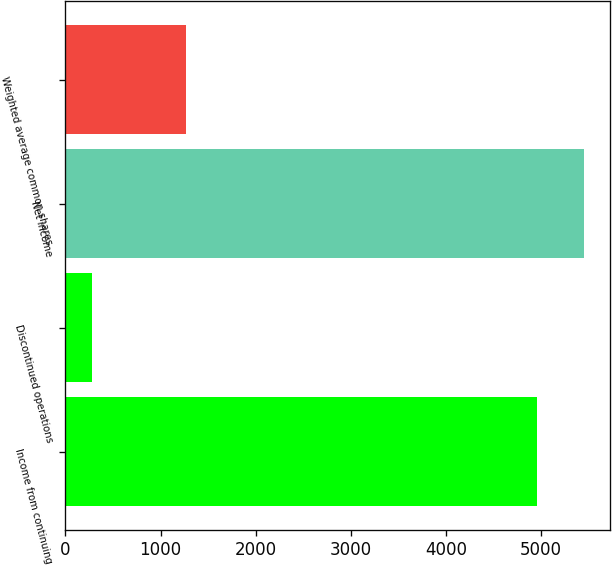<chart> <loc_0><loc_0><loc_500><loc_500><bar_chart><fcel>Income from continuing<fcel>Discontinued operations<fcel>Net income<fcel>Weighted average common shares<nl><fcel>4957<fcel>277<fcel>5452.7<fcel>1268.4<nl></chart> 